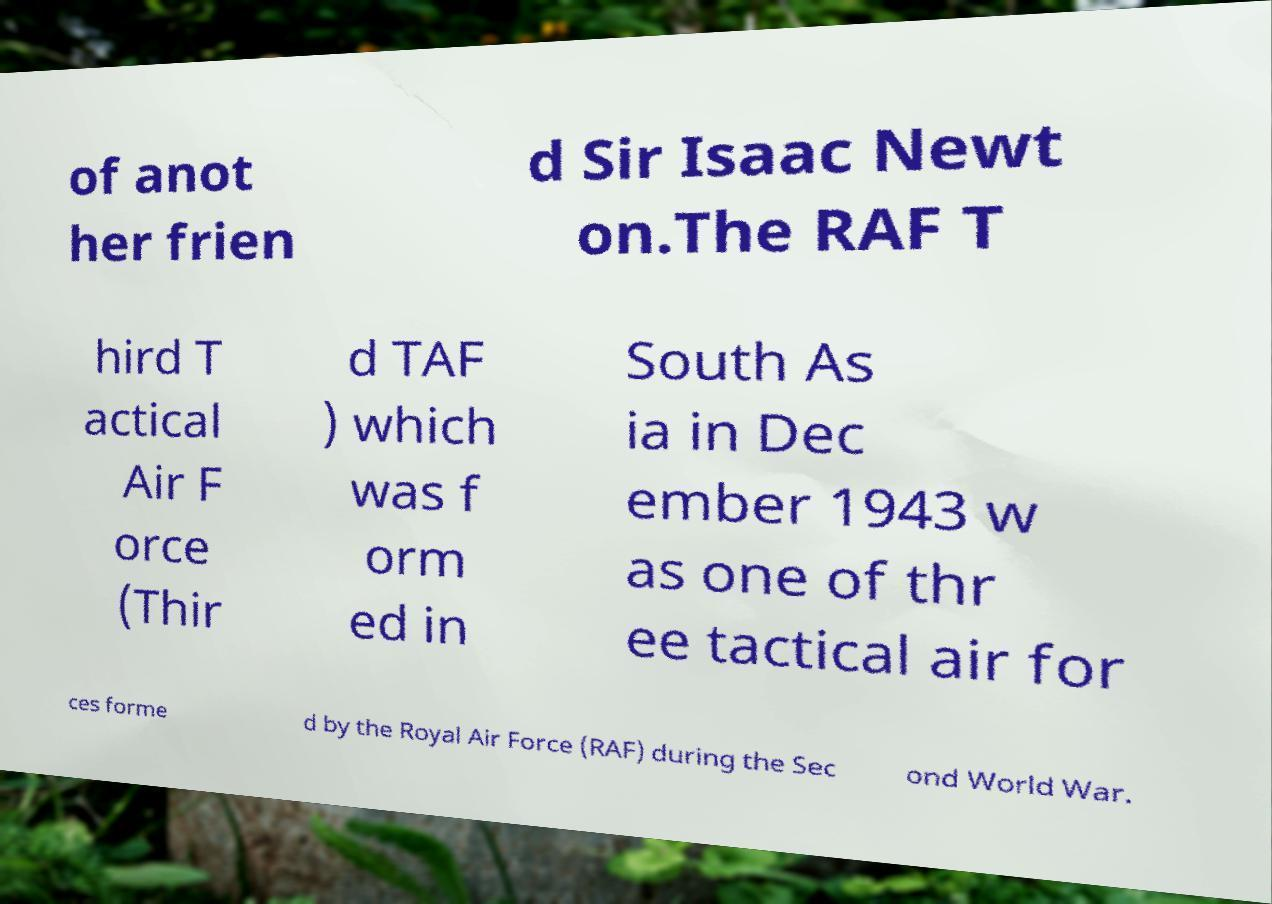Can you read and provide the text displayed in the image?This photo seems to have some interesting text. Can you extract and type it out for me? of anot her frien d Sir Isaac Newt on.The RAF T hird T actical Air F orce (Thir d TAF ) which was f orm ed in South As ia in Dec ember 1943 w as one of thr ee tactical air for ces forme d by the Royal Air Force (RAF) during the Sec ond World War. 